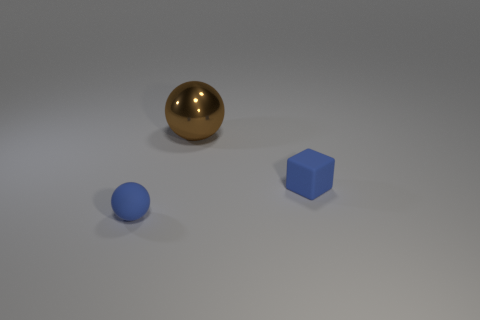There is a rubber object that is the same color as the cube; what is its size?
Offer a very short reply. Small. There is a brown sphere that is on the right side of the blue rubber sphere; is it the same size as the thing left of the large brown object?
Keep it short and to the point. No. There is a ball in front of the brown shiny thing; how big is it?
Provide a succinct answer. Small. Is there a big ball that has the same color as the big metallic object?
Give a very brief answer. No. Are there any tiny blue rubber blocks that are in front of the tiny rubber thing to the left of the big metal ball?
Your answer should be very brief. No. There is a blue cube; is it the same size as the blue rubber object on the left side of the tiny matte cube?
Keep it short and to the point. Yes. Is there a large brown metal sphere that is in front of the blue thing behind the tiny blue rubber thing that is left of the big sphere?
Give a very brief answer. No. What material is the tiny thing to the right of the large brown shiny object?
Keep it short and to the point. Rubber. Do the metallic object and the blue ball have the same size?
Your answer should be compact. No. What is the color of the object that is both on the left side of the blue cube and in front of the shiny thing?
Ensure brevity in your answer.  Blue. 